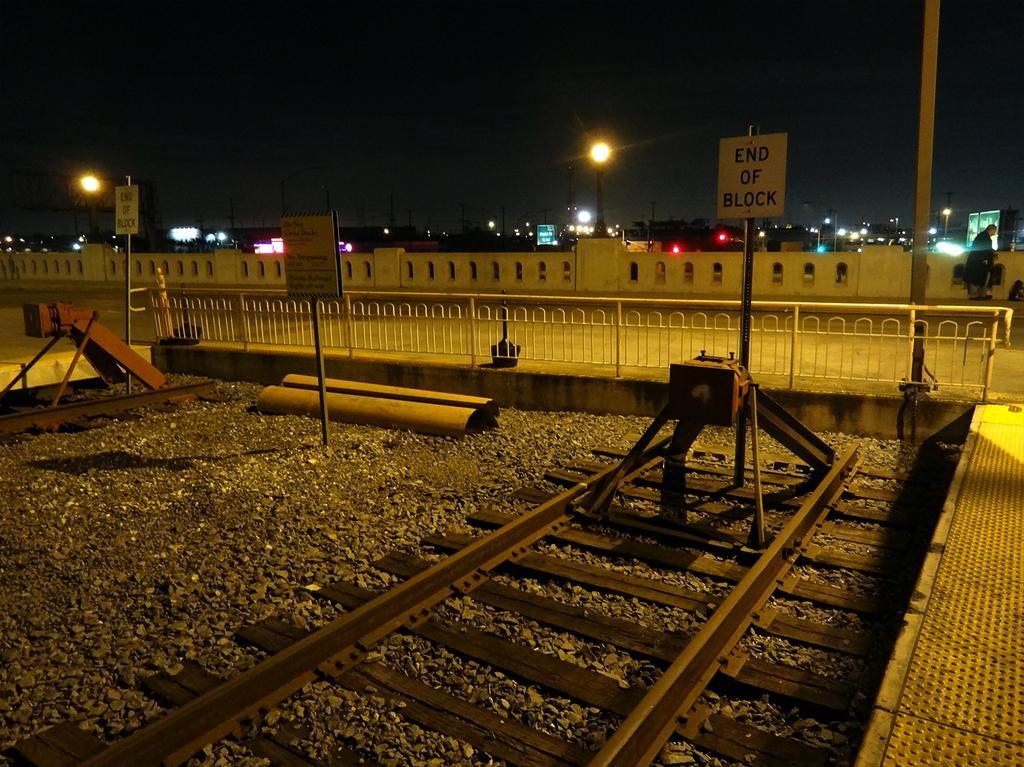How would you summarize this image in a sentence or two? In this image there is a railway track on the right side. It looks like it is a end of the track. In the background there are so many buildings and lights. On the right side bottom there is a platform. Behind the track there is a fence. There is a board which is fixed at the end of the track. 